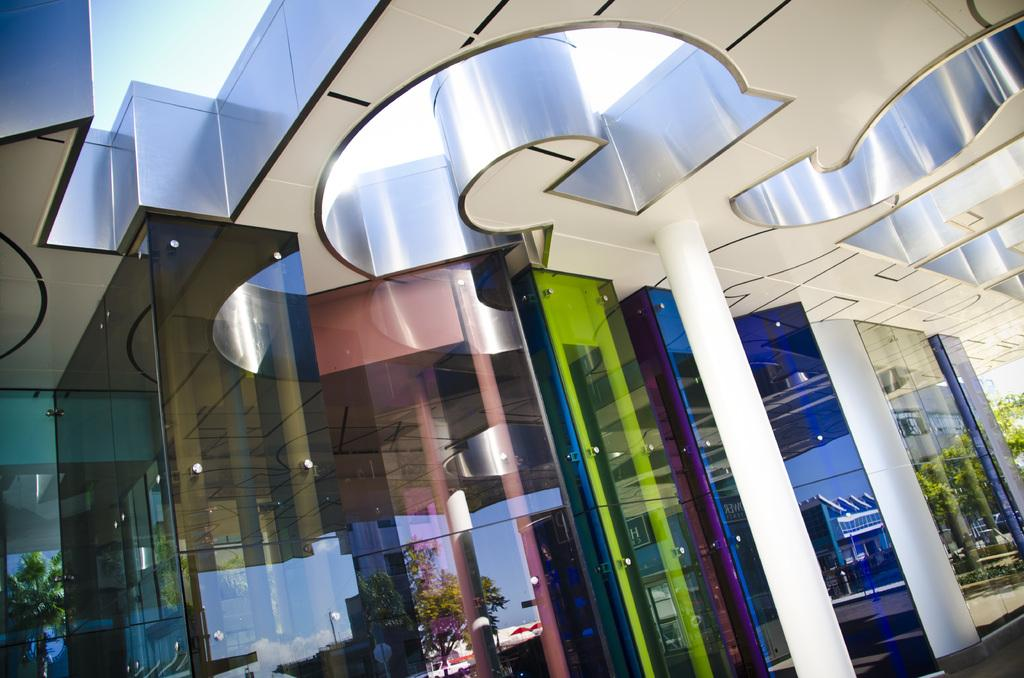What is the main structure visible in the image? There is a building in the image. What objects can be seen near the building? There are glasses of different colors in the image. What can be observed on the surface of the glasses? The glasses have reflections of buildings and trees. Where can the cherries be found in the image? There are no cherries present in the image. What type of door is visible in the image? There is no door visible in the image. 